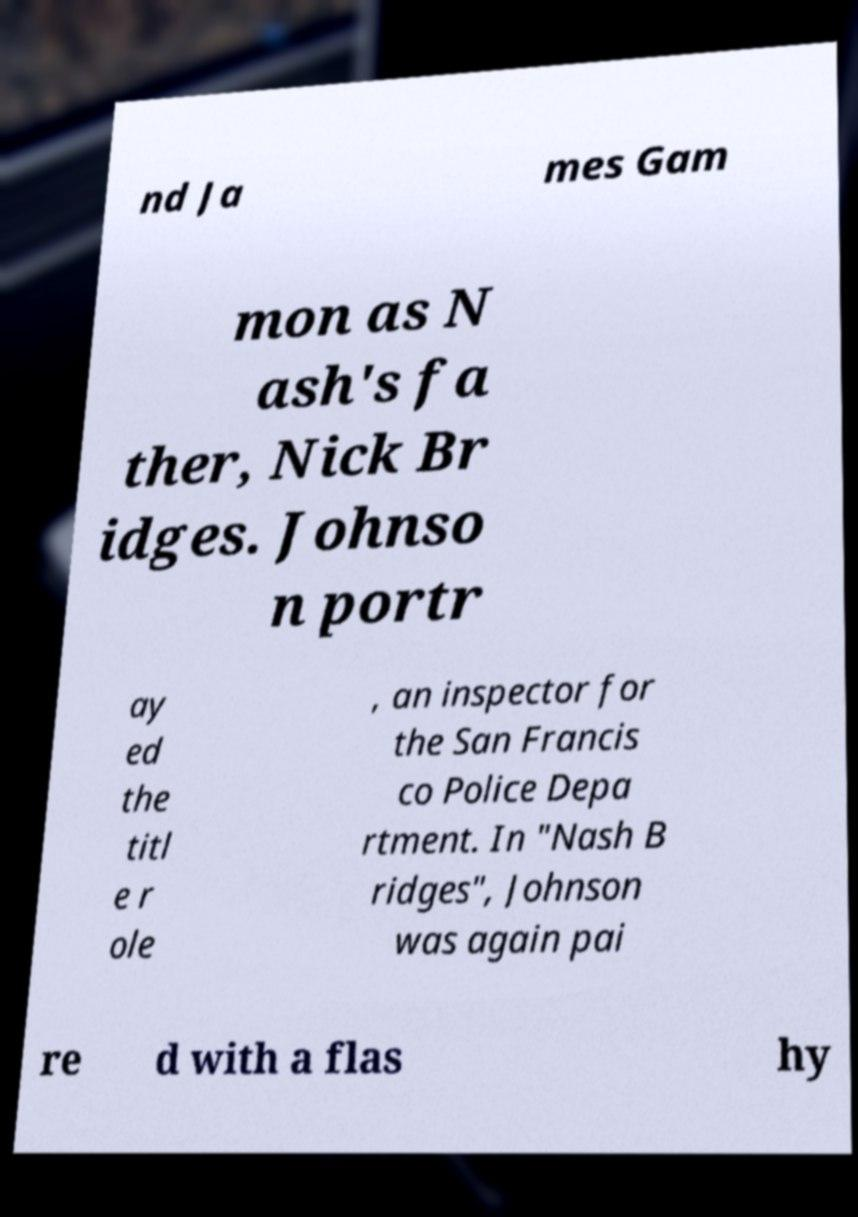What messages or text are displayed in this image? I need them in a readable, typed format. nd Ja mes Gam mon as N ash's fa ther, Nick Br idges. Johnso n portr ay ed the titl e r ole , an inspector for the San Francis co Police Depa rtment. In "Nash B ridges", Johnson was again pai re d with a flas hy 